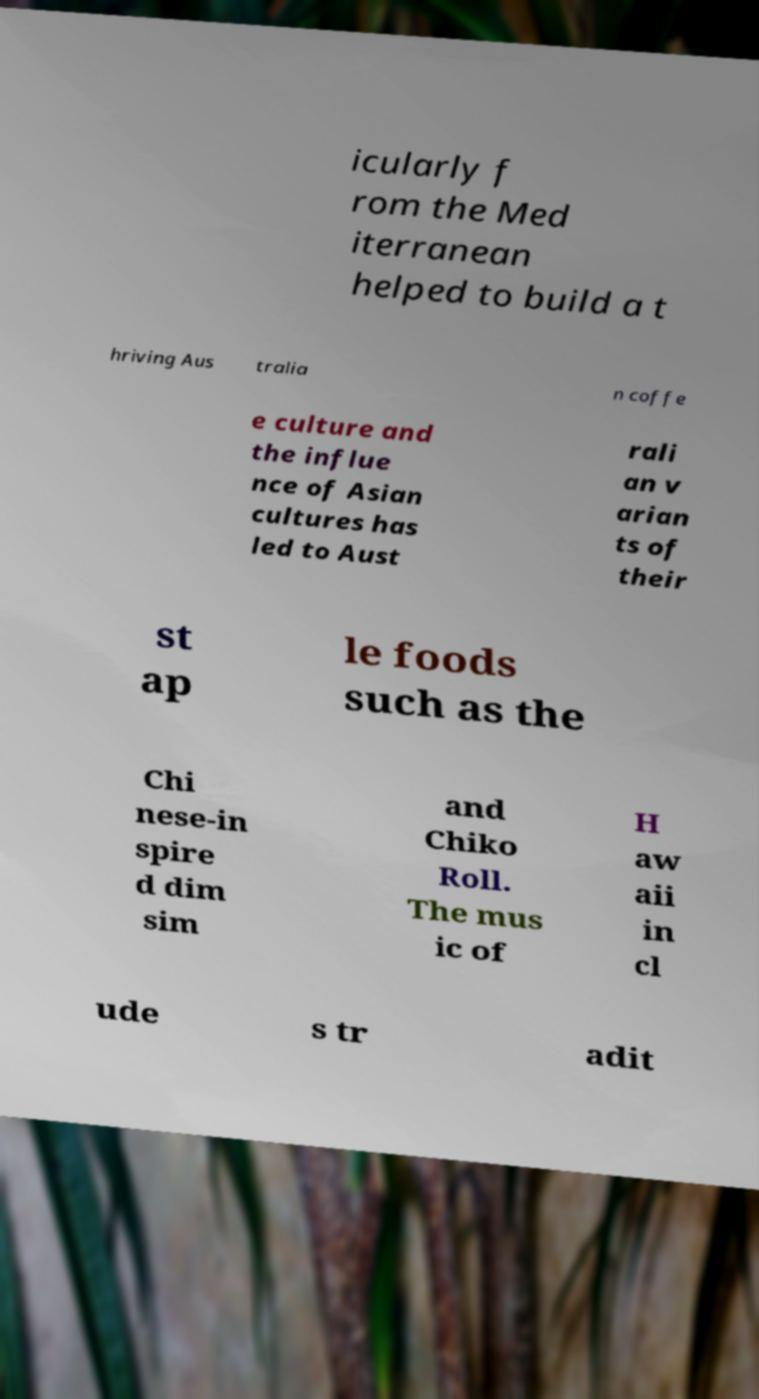Could you extract and type out the text from this image? icularly f rom the Med iterranean helped to build a t hriving Aus tralia n coffe e culture and the influe nce of Asian cultures has led to Aust rali an v arian ts of their st ap le foods such as the Chi nese-in spire d dim sim and Chiko Roll. The mus ic of H aw aii in cl ude s tr adit 